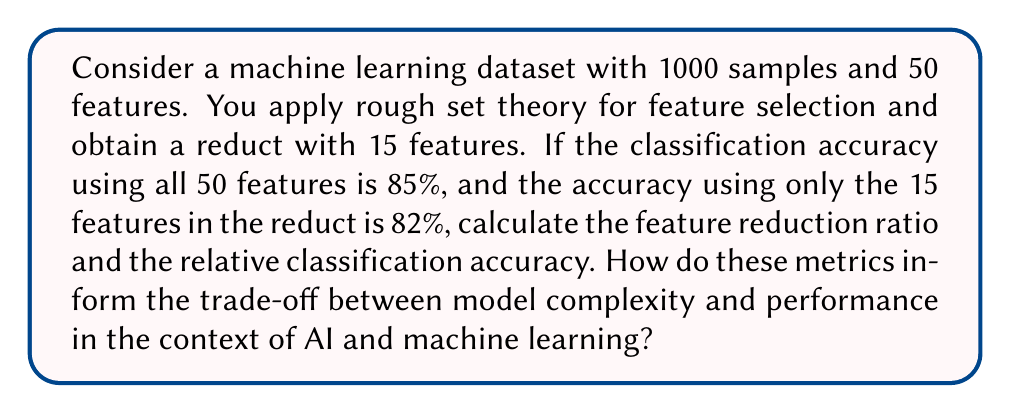Teach me how to tackle this problem. To solve this problem, we need to calculate two metrics:

1. Feature Reduction Ratio (FRR):
   The FRR measures the proportion of features that were removed while still maintaining a similar level of performance.

   $$ FRR = \frac{\text{Number of original features} - \text{Number of selected features}}{\text{Number of original features}} $$

   $$ FRR = \frac{50 - 15}{50} = \frac{35}{50} = 0.7 = 70\% $$

2. Relative Classification Accuracy (RCA):
   The RCA compares the accuracy of the model using the selected features to the accuracy of the model using all features.

   $$ RCA = \frac{\text{Accuracy with selected features}}{\text{Accuracy with all features}} \times 100\% $$

   $$ RCA = \frac{82\%}{85\%} \times 100\% = 96.47\% $$

These metrics inform the trade-off between model complexity and performance in AI and machine learning in the following ways:

1. The high FRR (70%) indicates that rough set theory has significantly reduced the number of features, potentially decreasing model complexity and computational requirements.

2. The high RCA (96.47%) suggests that the selected features maintain most of the original model's performance, despite using fewer features.

3. The slight drop in accuracy (from 85% to 82%) may be acceptable given the substantial reduction in features, depending on the specific requirements of the AI application.

4. This trade-off demonstrates the potential of rough set theory in feature selection for maintaining good performance while reducing model complexity, which can lead to more interpretable and efficient AI models.
Answer: Feature Reduction Ratio (FRR) = 70%
Relative Classification Accuracy (RCA) = 96.47%

These metrics indicate that rough set theory has effectively reduced the feature set by 70% while maintaining 96.47% of the original classification accuracy, demonstrating a favorable trade-off between model complexity and performance in AI and machine learning applications. 